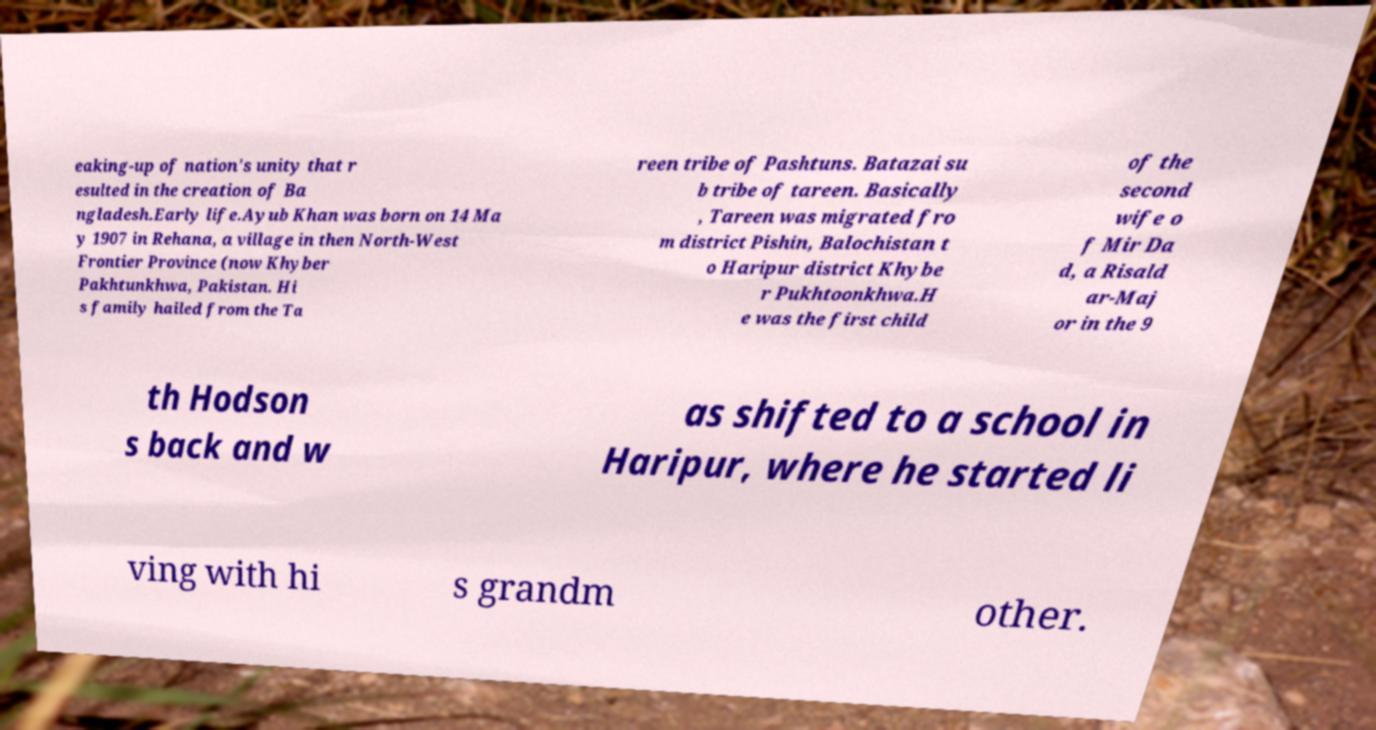Can you read and provide the text displayed in the image?This photo seems to have some interesting text. Can you extract and type it out for me? eaking-up of nation's unity that r esulted in the creation of Ba ngladesh.Early life.Ayub Khan was born on 14 Ma y 1907 in Rehana, a village in then North-West Frontier Province (now Khyber Pakhtunkhwa, Pakistan. Hi s family hailed from the Ta reen tribe of Pashtuns. Batazai su b tribe of tareen. Basically , Tareen was migrated fro m district Pishin, Balochistan t o Haripur district Khybe r Pukhtoonkhwa.H e was the first child of the second wife o f Mir Da d, a Risald ar-Maj or in the 9 th Hodson s back and w as shifted to a school in Haripur, where he started li ving with hi s grandm other. 